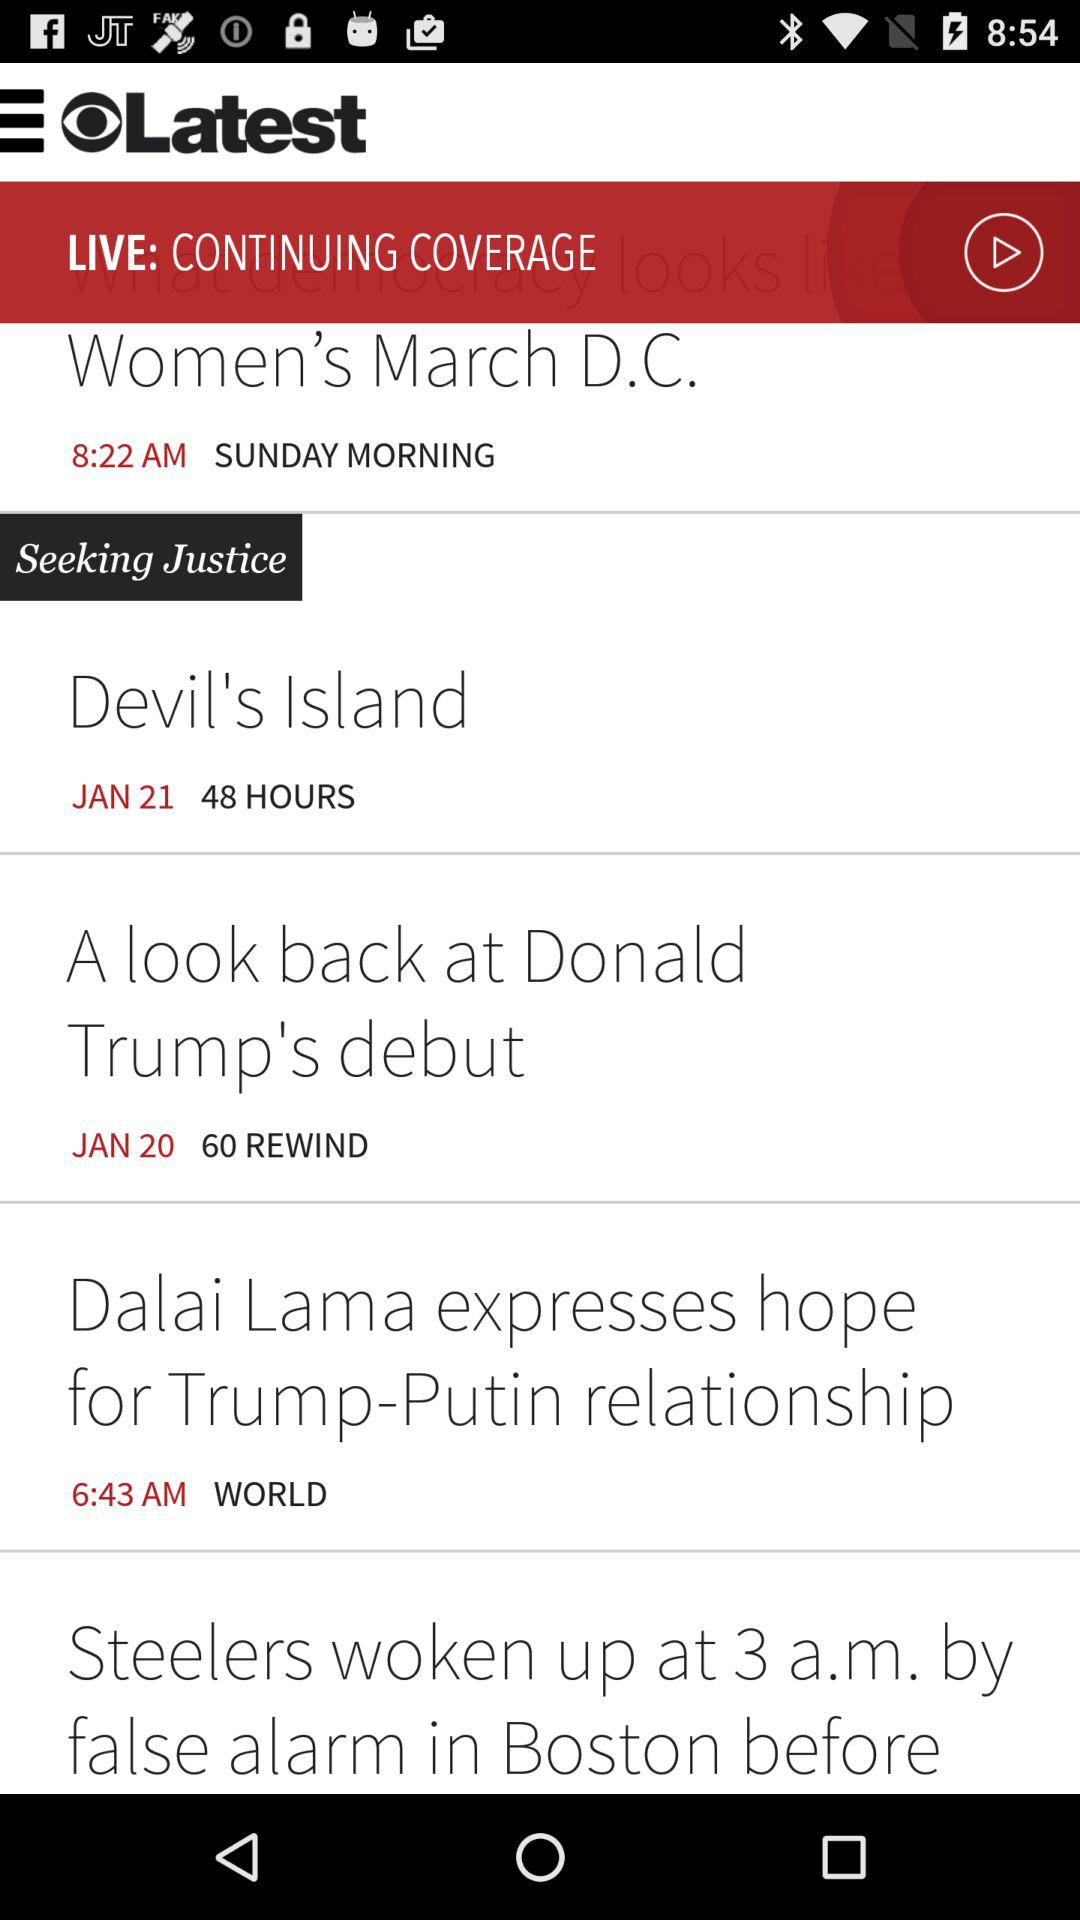What is the published time of the news "Dalai Lama expresses hope for Trump-Putin relationship"? The published time of the news is 6:43 AM. 